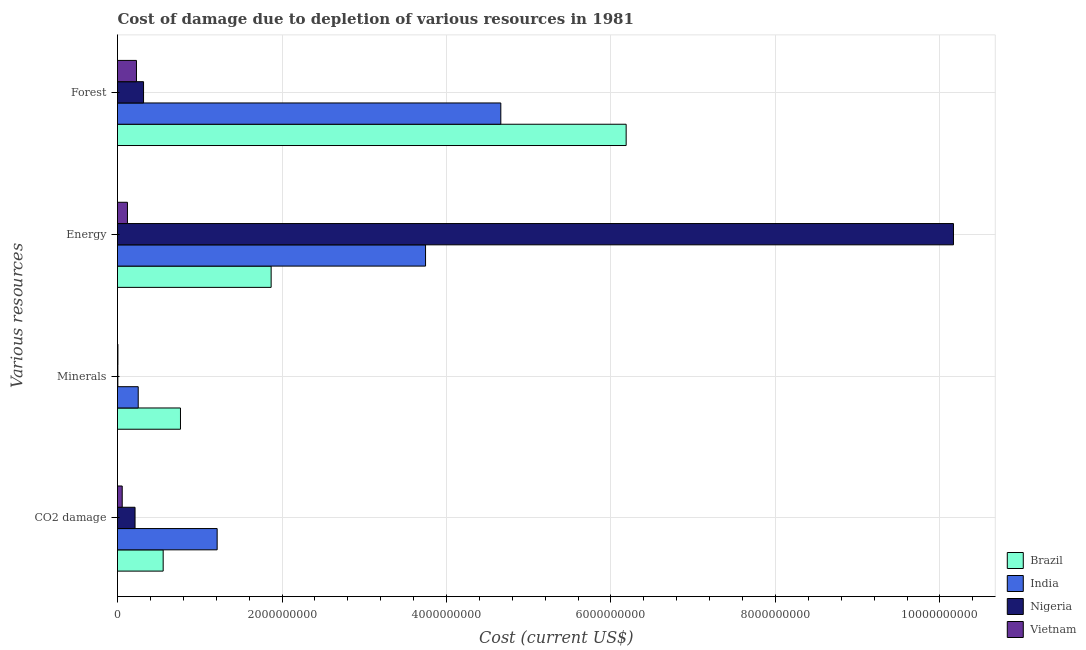How many different coloured bars are there?
Offer a terse response. 4. What is the label of the 3rd group of bars from the top?
Provide a short and direct response. Minerals. What is the cost of damage due to depletion of energy in Brazil?
Provide a short and direct response. 1.87e+09. Across all countries, what is the maximum cost of damage due to depletion of minerals?
Your response must be concise. 7.66e+08. Across all countries, what is the minimum cost of damage due to depletion of minerals?
Provide a succinct answer. 4.22e+06. In which country was the cost of damage due to depletion of energy maximum?
Your answer should be very brief. Nigeria. In which country was the cost of damage due to depletion of forests minimum?
Provide a succinct answer. Vietnam. What is the total cost of damage due to depletion of minerals in the graph?
Offer a terse response. 1.03e+09. What is the difference between the cost of damage due to depletion of coal in India and that in Vietnam?
Offer a very short reply. 1.15e+09. What is the difference between the cost of damage due to depletion of forests in Nigeria and the cost of damage due to depletion of minerals in India?
Make the answer very short. 6.48e+07. What is the average cost of damage due to depletion of energy per country?
Your answer should be compact. 3.97e+09. What is the difference between the cost of damage due to depletion of minerals and cost of damage due to depletion of energy in Brazil?
Provide a short and direct response. -1.10e+09. What is the ratio of the cost of damage due to depletion of coal in Vietnam to that in Brazil?
Give a very brief answer. 0.1. Is the cost of damage due to depletion of energy in Nigeria less than that in Brazil?
Offer a terse response. No. Is the difference between the cost of damage due to depletion of forests in India and Vietnam greater than the difference between the cost of damage due to depletion of coal in India and Vietnam?
Offer a terse response. Yes. What is the difference between the highest and the second highest cost of damage due to depletion of forests?
Your response must be concise. 1.52e+09. What is the difference between the highest and the lowest cost of damage due to depletion of minerals?
Your answer should be compact. 7.61e+08. What does the 3rd bar from the bottom in Energy represents?
Provide a succinct answer. Nigeria. Is it the case that in every country, the sum of the cost of damage due to depletion of coal and cost of damage due to depletion of minerals is greater than the cost of damage due to depletion of energy?
Make the answer very short. No. Are all the bars in the graph horizontal?
Your response must be concise. Yes. What is the difference between two consecutive major ticks on the X-axis?
Provide a succinct answer. 2.00e+09. Does the graph contain any zero values?
Your answer should be compact. No. Does the graph contain grids?
Your response must be concise. Yes. Where does the legend appear in the graph?
Give a very brief answer. Bottom right. How many legend labels are there?
Your response must be concise. 4. How are the legend labels stacked?
Your answer should be very brief. Vertical. What is the title of the graph?
Ensure brevity in your answer.  Cost of damage due to depletion of various resources in 1981 . What is the label or title of the X-axis?
Your answer should be very brief. Cost (current US$). What is the label or title of the Y-axis?
Provide a succinct answer. Various resources. What is the Cost (current US$) of Brazil in CO2 damage?
Make the answer very short. 5.55e+08. What is the Cost (current US$) of India in CO2 damage?
Ensure brevity in your answer.  1.21e+09. What is the Cost (current US$) of Nigeria in CO2 damage?
Provide a short and direct response. 2.13e+08. What is the Cost (current US$) of Vietnam in CO2 damage?
Offer a terse response. 5.73e+07. What is the Cost (current US$) of Brazil in Minerals?
Make the answer very short. 7.66e+08. What is the Cost (current US$) in India in Minerals?
Offer a terse response. 2.52e+08. What is the Cost (current US$) of Nigeria in Minerals?
Offer a very short reply. 4.22e+06. What is the Cost (current US$) in Vietnam in Minerals?
Your answer should be compact. 5.06e+06. What is the Cost (current US$) in Brazil in Energy?
Provide a succinct answer. 1.87e+09. What is the Cost (current US$) of India in Energy?
Provide a short and direct response. 3.75e+09. What is the Cost (current US$) in Nigeria in Energy?
Give a very brief answer. 1.02e+1. What is the Cost (current US$) in Vietnam in Energy?
Offer a terse response. 1.21e+08. What is the Cost (current US$) in Brazil in Forest?
Give a very brief answer. 6.18e+09. What is the Cost (current US$) of India in Forest?
Give a very brief answer. 4.66e+09. What is the Cost (current US$) of Nigeria in Forest?
Your answer should be very brief. 3.17e+08. What is the Cost (current US$) of Vietnam in Forest?
Your response must be concise. 2.31e+08. Across all Various resources, what is the maximum Cost (current US$) in Brazil?
Provide a succinct answer. 6.18e+09. Across all Various resources, what is the maximum Cost (current US$) in India?
Offer a terse response. 4.66e+09. Across all Various resources, what is the maximum Cost (current US$) of Nigeria?
Offer a terse response. 1.02e+1. Across all Various resources, what is the maximum Cost (current US$) of Vietnam?
Offer a very short reply. 2.31e+08. Across all Various resources, what is the minimum Cost (current US$) of Brazil?
Offer a terse response. 5.55e+08. Across all Various resources, what is the minimum Cost (current US$) of India?
Provide a short and direct response. 2.52e+08. Across all Various resources, what is the minimum Cost (current US$) of Nigeria?
Your answer should be very brief. 4.22e+06. Across all Various resources, what is the minimum Cost (current US$) of Vietnam?
Make the answer very short. 5.06e+06. What is the total Cost (current US$) in Brazil in the graph?
Make the answer very short. 9.37e+09. What is the total Cost (current US$) of India in the graph?
Offer a very short reply. 9.87e+09. What is the total Cost (current US$) in Nigeria in the graph?
Your answer should be compact. 1.07e+1. What is the total Cost (current US$) in Vietnam in the graph?
Your response must be concise. 4.14e+08. What is the difference between the Cost (current US$) in Brazil in CO2 damage and that in Minerals?
Ensure brevity in your answer.  -2.10e+08. What is the difference between the Cost (current US$) of India in CO2 damage and that in Minerals?
Your response must be concise. 9.60e+08. What is the difference between the Cost (current US$) in Nigeria in CO2 damage and that in Minerals?
Your response must be concise. 2.09e+08. What is the difference between the Cost (current US$) of Vietnam in CO2 damage and that in Minerals?
Make the answer very short. 5.22e+07. What is the difference between the Cost (current US$) in Brazil in CO2 damage and that in Energy?
Your response must be concise. -1.31e+09. What is the difference between the Cost (current US$) in India in CO2 damage and that in Energy?
Your answer should be very brief. -2.53e+09. What is the difference between the Cost (current US$) of Nigeria in CO2 damage and that in Energy?
Your answer should be compact. -9.95e+09. What is the difference between the Cost (current US$) in Vietnam in CO2 damage and that in Energy?
Ensure brevity in your answer.  -6.37e+07. What is the difference between the Cost (current US$) of Brazil in CO2 damage and that in Forest?
Keep it short and to the point. -5.63e+09. What is the difference between the Cost (current US$) in India in CO2 damage and that in Forest?
Ensure brevity in your answer.  -3.45e+09. What is the difference between the Cost (current US$) of Nigeria in CO2 damage and that in Forest?
Your answer should be very brief. -1.03e+08. What is the difference between the Cost (current US$) in Vietnam in CO2 damage and that in Forest?
Your response must be concise. -1.73e+08. What is the difference between the Cost (current US$) of Brazil in Minerals and that in Energy?
Provide a succinct answer. -1.10e+09. What is the difference between the Cost (current US$) in India in Minerals and that in Energy?
Provide a short and direct response. -3.49e+09. What is the difference between the Cost (current US$) of Nigeria in Minerals and that in Energy?
Keep it short and to the point. -1.02e+1. What is the difference between the Cost (current US$) in Vietnam in Minerals and that in Energy?
Give a very brief answer. -1.16e+08. What is the difference between the Cost (current US$) in Brazil in Minerals and that in Forest?
Offer a very short reply. -5.42e+09. What is the difference between the Cost (current US$) of India in Minerals and that in Forest?
Keep it short and to the point. -4.41e+09. What is the difference between the Cost (current US$) of Nigeria in Minerals and that in Forest?
Keep it short and to the point. -3.12e+08. What is the difference between the Cost (current US$) in Vietnam in Minerals and that in Forest?
Provide a short and direct response. -2.26e+08. What is the difference between the Cost (current US$) in Brazil in Energy and that in Forest?
Offer a very short reply. -4.32e+09. What is the difference between the Cost (current US$) in India in Energy and that in Forest?
Your response must be concise. -9.15e+08. What is the difference between the Cost (current US$) of Nigeria in Energy and that in Forest?
Ensure brevity in your answer.  9.85e+09. What is the difference between the Cost (current US$) of Vietnam in Energy and that in Forest?
Ensure brevity in your answer.  -1.10e+08. What is the difference between the Cost (current US$) of Brazil in CO2 damage and the Cost (current US$) of India in Minerals?
Offer a terse response. 3.03e+08. What is the difference between the Cost (current US$) in Brazil in CO2 damage and the Cost (current US$) in Nigeria in Minerals?
Your response must be concise. 5.51e+08. What is the difference between the Cost (current US$) in Brazil in CO2 damage and the Cost (current US$) in Vietnam in Minerals?
Your response must be concise. 5.50e+08. What is the difference between the Cost (current US$) of India in CO2 damage and the Cost (current US$) of Nigeria in Minerals?
Your answer should be very brief. 1.21e+09. What is the difference between the Cost (current US$) in India in CO2 damage and the Cost (current US$) in Vietnam in Minerals?
Give a very brief answer. 1.21e+09. What is the difference between the Cost (current US$) of Nigeria in CO2 damage and the Cost (current US$) of Vietnam in Minerals?
Provide a short and direct response. 2.08e+08. What is the difference between the Cost (current US$) in Brazil in CO2 damage and the Cost (current US$) in India in Energy?
Offer a very short reply. -3.19e+09. What is the difference between the Cost (current US$) in Brazil in CO2 damage and the Cost (current US$) in Nigeria in Energy?
Your answer should be very brief. -9.61e+09. What is the difference between the Cost (current US$) of Brazil in CO2 damage and the Cost (current US$) of Vietnam in Energy?
Provide a short and direct response. 4.34e+08. What is the difference between the Cost (current US$) of India in CO2 damage and the Cost (current US$) of Nigeria in Energy?
Offer a terse response. -8.95e+09. What is the difference between the Cost (current US$) of India in CO2 damage and the Cost (current US$) of Vietnam in Energy?
Your answer should be very brief. 1.09e+09. What is the difference between the Cost (current US$) in Nigeria in CO2 damage and the Cost (current US$) in Vietnam in Energy?
Provide a short and direct response. 9.22e+07. What is the difference between the Cost (current US$) in Brazil in CO2 damage and the Cost (current US$) in India in Forest?
Provide a short and direct response. -4.11e+09. What is the difference between the Cost (current US$) in Brazil in CO2 damage and the Cost (current US$) in Nigeria in Forest?
Provide a succinct answer. 2.39e+08. What is the difference between the Cost (current US$) in Brazil in CO2 damage and the Cost (current US$) in Vietnam in Forest?
Your response must be concise. 3.25e+08. What is the difference between the Cost (current US$) in India in CO2 damage and the Cost (current US$) in Nigeria in Forest?
Your answer should be compact. 8.95e+08. What is the difference between the Cost (current US$) in India in CO2 damage and the Cost (current US$) in Vietnam in Forest?
Ensure brevity in your answer.  9.81e+08. What is the difference between the Cost (current US$) in Nigeria in CO2 damage and the Cost (current US$) in Vietnam in Forest?
Make the answer very short. -1.74e+07. What is the difference between the Cost (current US$) in Brazil in Minerals and the Cost (current US$) in India in Energy?
Your response must be concise. -2.98e+09. What is the difference between the Cost (current US$) of Brazil in Minerals and the Cost (current US$) of Nigeria in Energy?
Make the answer very short. -9.40e+09. What is the difference between the Cost (current US$) in Brazil in Minerals and the Cost (current US$) in Vietnam in Energy?
Ensure brevity in your answer.  6.44e+08. What is the difference between the Cost (current US$) of India in Minerals and the Cost (current US$) of Nigeria in Energy?
Your response must be concise. -9.91e+09. What is the difference between the Cost (current US$) in India in Minerals and the Cost (current US$) in Vietnam in Energy?
Ensure brevity in your answer.  1.31e+08. What is the difference between the Cost (current US$) of Nigeria in Minerals and the Cost (current US$) of Vietnam in Energy?
Provide a succinct answer. -1.17e+08. What is the difference between the Cost (current US$) of Brazil in Minerals and the Cost (current US$) of India in Forest?
Provide a short and direct response. -3.90e+09. What is the difference between the Cost (current US$) of Brazil in Minerals and the Cost (current US$) of Nigeria in Forest?
Provide a succinct answer. 4.49e+08. What is the difference between the Cost (current US$) in Brazil in Minerals and the Cost (current US$) in Vietnam in Forest?
Your response must be concise. 5.35e+08. What is the difference between the Cost (current US$) of India in Minerals and the Cost (current US$) of Nigeria in Forest?
Provide a short and direct response. -6.48e+07. What is the difference between the Cost (current US$) in India in Minerals and the Cost (current US$) in Vietnam in Forest?
Your response must be concise. 2.14e+07. What is the difference between the Cost (current US$) in Nigeria in Minerals and the Cost (current US$) in Vietnam in Forest?
Your answer should be very brief. -2.26e+08. What is the difference between the Cost (current US$) of Brazil in Energy and the Cost (current US$) of India in Forest?
Your answer should be compact. -2.79e+09. What is the difference between the Cost (current US$) of Brazil in Energy and the Cost (current US$) of Nigeria in Forest?
Your answer should be compact. 1.55e+09. What is the difference between the Cost (current US$) in Brazil in Energy and the Cost (current US$) in Vietnam in Forest?
Your response must be concise. 1.64e+09. What is the difference between the Cost (current US$) of India in Energy and the Cost (current US$) of Nigeria in Forest?
Provide a short and direct response. 3.43e+09. What is the difference between the Cost (current US$) of India in Energy and the Cost (current US$) of Vietnam in Forest?
Ensure brevity in your answer.  3.51e+09. What is the difference between the Cost (current US$) of Nigeria in Energy and the Cost (current US$) of Vietnam in Forest?
Offer a terse response. 9.93e+09. What is the average Cost (current US$) in Brazil per Various resources?
Provide a succinct answer. 2.34e+09. What is the average Cost (current US$) in India per Various resources?
Make the answer very short. 2.47e+09. What is the average Cost (current US$) of Nigeria per Various resources?
Offer a very short reply. 2.67e+09. What is the average Cost (current US$) of Vietnam per Various resources?
Give a very brief answer. 1.03e+08. What is the difference between the Cost (current US$) of Brazil and Cost (current US$) of India in CO2 damage?
Your response must be concise. -6.56e+08. What is the difference between the Cost (current US$) of Brazil and Cost (current US$) of Nigeria in CO2 damage?
Offer a terse response. 3.42e+08. What is the difference between the Cost (current US$) in Brazil and Cost (current US$) in Vietnam in CO2 damage?
Provide a short and direct response. 4.98e+08. What is the difference between the Cost (current US$) of India and Cost (current US$) of Nigeria in CO2 damage?
Make the answer very short. 9.98e+08. What is the difference between the Cost (current US$) in India and Cost (current US$) in Vietnam in CO2 damage?
Your response must be concise. 1.15e+09. What is the difference between the Cost (current US$) in Nigeria and Cost (current US$) in Vietnam in CO2 damage?
Keep it short and to the point. 1.56e+08. What is the difference between the Cost (current US$) of Brazil and Cost (current US$) of India in Minerals?
Your answer should be very brief. 5.14e+08. What is the difference between the Cost (current US$) in Brazil and Cost (current US$) in Nigeria in Minerals?
Keep it short and to the point. 7.61e+08. What is the difference between the Cost (current US$) of Brazil and Cost (current US$) of Vietnam in Minerals?
Your response must be concise. 7.60e+08. What is the difference between the Cost (current US$) in India and Cost (current US$) in Nigeria in Minerals?
Keep it short and to the point. 2.48e+08. What is the difference between the Cost (current US$) in India and Cost (current US$) in Vietnam in Minerals?
Provide a short and direct response. 2.47e+08. What is the difference between the Cost (current US$) in Nigeria and Cost (current US$) in Vietnam in Minerals?
Your answer should be compact. -8.33e+05. What is the difference between the Cost (current US$) in Brazil and Cost (current US$) in India in Energy?
Provide a short and direct response. -1.88e+09. What is the difference between the Cost (current US$) in Brazil and Cost (current US$) in Nigeria in Energy?
Your answer should be very brief. -8.30e+09. What is the difference between the Cost (current US$) in Brazil and Cost (current US$) in Vietnam in Energy?
Give a very brief answer. 1.75e+09. What is the difference between the Cost (current US$) in India and Cost (current US$) in Nigeria in Energy?
Offer a very short reply. -6.42e+09. What is the difference between the Cost (current US$) in India and Cost (current US$) in Vietnam in Energy?
Your answer should be very brief. 3.62e+09. What is the difference between the Cost (current US$) of Nigeria and Cost (current US$) of Vietnam in Energy?
Offer a very short reply. 1.00e+1. What is the difference between the Cost (current US$) of Brazil and Cost (current US$) of India in Forest?
Make the answer very short. 1.52e+09. What is the difference between the Cost (current US$) of Brazil and Cost (current US$) of Nigeria in Forest?
Provide a short and direct response. 5.87e+09. What is the difference between the Cost (current US$) in Brazil and Cost (current US$) in Vietnam in Forest?
Ensure brevity in your answer.  5.95e+09. What is the difference between the Cost (current US$) in India and Cost (current US$) in Nigeria in Forest?
Your answer should be compact. 4.34e+09. What is the difference between the Cost (current US$) in India and Cost (current US$) in Vietnam in Forest?
Provide a succinct answer. 4.43e+09. What is the difference between the Cost (current US$) of Nigeria and Cost (current US$) of Vietnam in Forest?
Provide a short and direct response. 8.61e+07. What is the ratio of the Cost (current US$) in Brazil in CO2 damage to that in Minerals?
Your answer should be very brief. 0.73. What is the ratio of the Cost (current US$) of India in CO2 damage to that in Minerals?
Your answer should be very brief. 4.81. What is the ratio of the Cost (current US$) in Nigeria in CO2 damage to that in Minerals?
Ensure brevity in your answer.  50.49. What is the ratio of the Cost (current US$) in Vietnam in CO2 damage to that in Minerals?
Ensure brevity in your answer.  11.33. What is the ratio of the Cost (current US$) of Brazil in CO2 damage to that in Energy?
Your answer should be very brief. 0.3. What is the ratio of the Cost (current US$) of India in CO2 damage to that in Energy?
Make the answer very short. 0.32. What is the ratio of the Cost (current US$) in Nigeria in CO2 damage to that in Energy?
Give a very brief answer. 0.02. What is the ratio of the Cost (current US$) in Vietnam in CO2 damage to that in Energy?
Offer a very short reply. 0.47. What is the ratio of the Cost (current US$) in Brazil in CO2 damage to that in Forest?
Give a very brief answer. 0.09. What is the ratio of the Cost (current US$) of India in CO2 damage to that in Forest?
Offer a very short reply. 0.26. What is the ratio of the Cost (current US$) of Nigeria in CO2 damage to that in Forest?
Make the answer very short. 0.67. What is the ratio of the Cost (current US$) in Vietnam in CO2 damage to that in Forest?
Make the answer very short. 0.25. What is the ratio of the Cost (current US$) of Brazil in Minerals to that in Energy?
Provide a succinct answer. 0.41. What is the ratio of the Cost (current US$) of India in Minerals to that in Energy?
Offer a terse response. 0.07. What is the ratio of the Cost (current US$) of Nigeria in Minerals to that in Energy?
Keep it short and to the point. 0. What is the ratio of the Cost (current US$) of Vietnam in Minerals to that in Energy?
Make the answer very short. 0.04. What is the ratio of the Cost (current US$) of Brazil in Minerals to that in Forest?
Your answer should be compact. 0.12. What is the ratio of the Cost (current US$) of India in Minerals to that in Forest?
Keep it short and to the point. 0.05. What is the ratio of the Cost (current US$) in Nigeria in Minerals to that in Forest?
Provide a short and direct response. 0.01. What is the ratio of the Cost (current US$) in Vietnam in Minerals to that in Forest?
Make the answer very short. 0.02. What is the ratio of the Cost (current US$) in Brazil in Energy to that in Forest?
Provide a succinct answer. 0.3. What is the ratio of the Cost (current US$) of India in Energy to that in Forest?
Provide a succinct answer. 0.8. What is the ratio of the Cost (current US$) in Nigeria in Energy to that in Forest?
Make the answer very short. 32.1. What is the ratio of the Cost (current US$) in Vietnam in Energy to that in Forest?
Your answer should be compact. 0.53. What is the difference between the highest and the second highest Cost (current US$) of Brazil?
Your answer should be compact. 4.32e+09. What is the difference between the highest and the second highest Cost (current US$) in India?
Provide a succinct answer. 9.15e+08. What is the difference between the highest and the second highest Cost (current US$) of Nigeria?
Keep it short and to the point. 9.85e+09. What is the difference between the highest and the second highest Cost (current US$) in Vietnam?
Keep it short and to the point. 1.10e+08. What is the difference between the highest and the lowest Cost (current US$) in Brazil?
Provide a succinct answer. 5.63e+09. What is the difference between the highest and the lowest Cost (current US$) in India?
Your answer should be compact. 4.41e+09. What is the difference between the highest and the lowest Cost (current US$) in Nigeria?
Provide a short and direct response. 1.02e+1. What is the difference between the highest and the lowest Cost (current US$) in Vietnam?
Provide a succinct answer. 2.26e+08. 